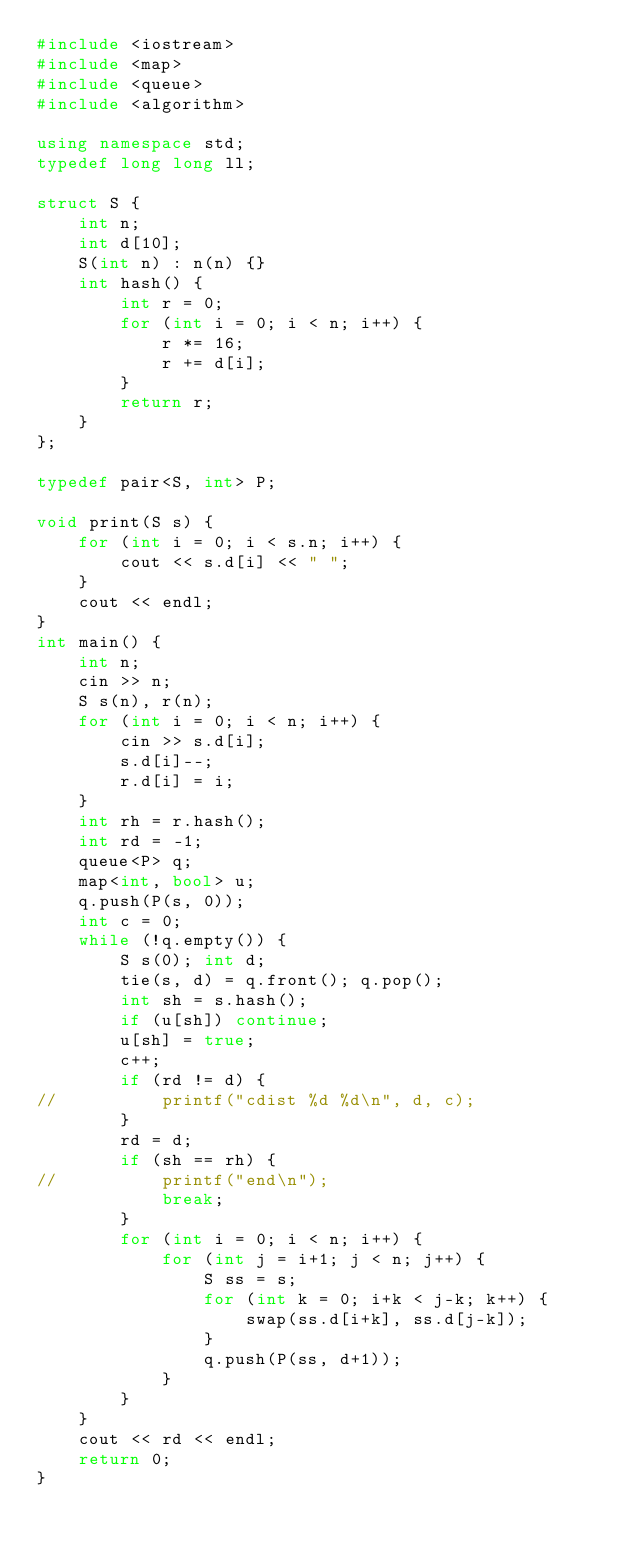<code> <loc_0><loc_0><loc_500><loc_500><_C++_>#include <iostream>
#include <map>
#include <queue>
#include <algorithm>

using namespace std;
typedef long long ll;

struct S {
	int n;
	int d[10];
	S(int n) : n(n) {}
	int hash() {
		int r = 0;
		for (int i = 0; i < n; i++) {
			r *= 16;
			r += d[i];
		}
		return r;
	}
};

typedef pair<S, int> P;

void print(S s) {
	for (int i = 0; i < s.n; i++) {
		cout << s.d[i] << " ";
	}
	cout << endl;
}
int main() {
	int n;
	cin >> n;
	S s(n), r(n);
	for (int i = 0; i < n; i++) {
		cin >> s.d[i];
		s.d[i]--;
		r.d[i] = i;
	}
	int rh = r.hash();
	int rd = -1;
	queue<P> q;
	map<int, bool> u;
	q.push(P(s, 0));
	int c = 0;
	while (!q.empty()) {
		S s(0); int d;
		tie(s, d) = q.front(); q.pop();
		int sh = s.hash();
		if (u[sh]) continue;
		u[sh] = true;
		c++;
		if (rd != d) {
//			printf("cdist %d %d\n", d, c);
		}
		rd = d;
		if (sh == rh) {
//			printf("end\n");
			break;
		}
		for (int i = 0; i < n; i++) {
			for (int j = i+1; j < n; j++) {
				S ss = s;
				for (int k = 0; i+k < j-k; k++) {
					swap(ss.d[i+k], ss.d[j-k]);
				}
				q.push(P(ss, d+1));
			}
		}
	}
	cout << rd << endl;
	return 0;
}</code> 